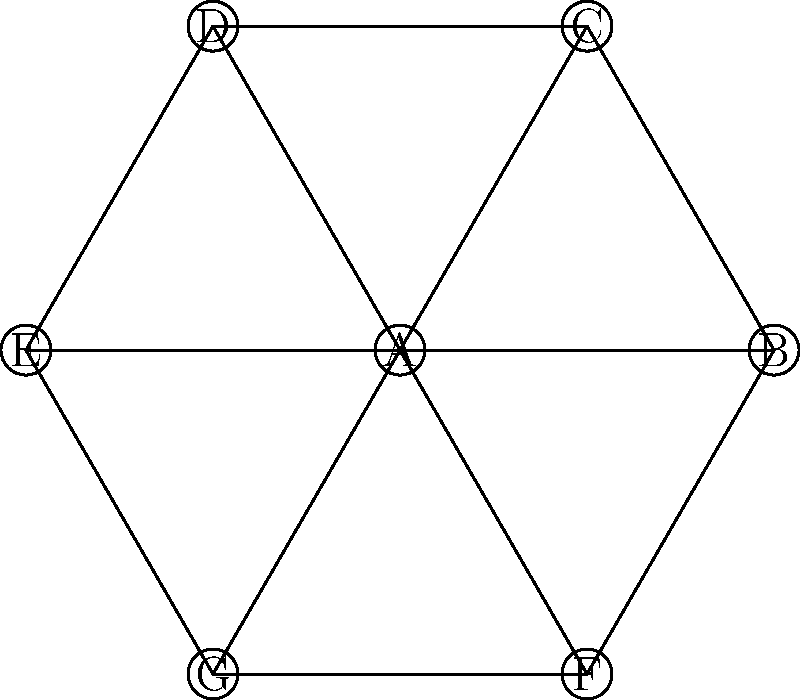In the given network diagram, which node has the highest degree centrality (i.e., the most direct connections to other nodes)? What is its degree? To determine the node with the highest degree centrality and its degree, we need to count the number of direct connections (edges) for each node:

1. Node A: Connected to B, C, D, E, F, G (6 connections)
2. Node B: Connected to A, C, F (3 connections)
3. Node C: Connected to A, B, D (3 connections)
4. Node D: Connected to A, C, E (3 connections)
5. Node E: Connected to A, D, G (3 connections)
6. Node F: Connected to A, B, G (3 connections)
7. Node G: Connected to A, E, F (3 connections)

From this analysis, we can see that Node A has the highest degree centrality with 6 connections.

The degree of Node A is 6.
Answer: Node A, degree 6 